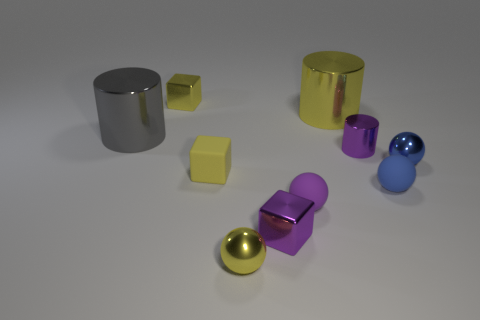Can you tell me what the largest object in the scene is and what it looks like? The largest object in this scene seems to be a cylindrical container, possibly a canister, with a highly reflective metallic surface. It has a golden hue and is on the right side of the image, standing vertically with a flat top. 